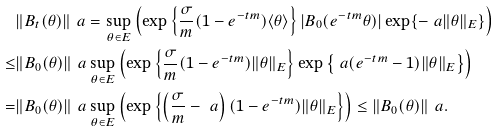Convert formula to latex. <formula><loc_0><loc_0><loc_500><loc_500>& \| B _ { t } ( \theta ) \| _ { \ } a = \sup _ { \theta \in E } \left ( \exp \left \{ \frac { \sigma } { m } ( 1 - e ^ { - t m } ) \langle \theta \rangle \right \} | B _ { 0 } ( e ^ { - t m } \theta ) | \exp \{ - \ a \| \theta \| _ { E } \} \right ) \\ \leq & \| B _ { 0 } ( \theta ) \| _ { \ } a \sup _ { \theta \in E } \left ( \exp \left \{ \frac { \sigma } { m } ( 1 - e ^ { - t m } ) \| \theta \| _ { E } \right \} \exp \left \{ \ a ( e ^ { - t m } - 1 ) \| \theta \| _ { E } \right \} \right ) \\ = & \| B _ { 0 } ( \theta ) \| _ { \ } a \sup _ { \theta \in E } \left ( \exp \left \{ \left ( \frac { \sigma } { m } - \ a \right ) ( 1 - e ^ { - t m } ) \| \theta \| _ { E } \right \} \right ) \leq \| B _ { 0 } ( \theta ) \| _ { \ } a .</formula> 